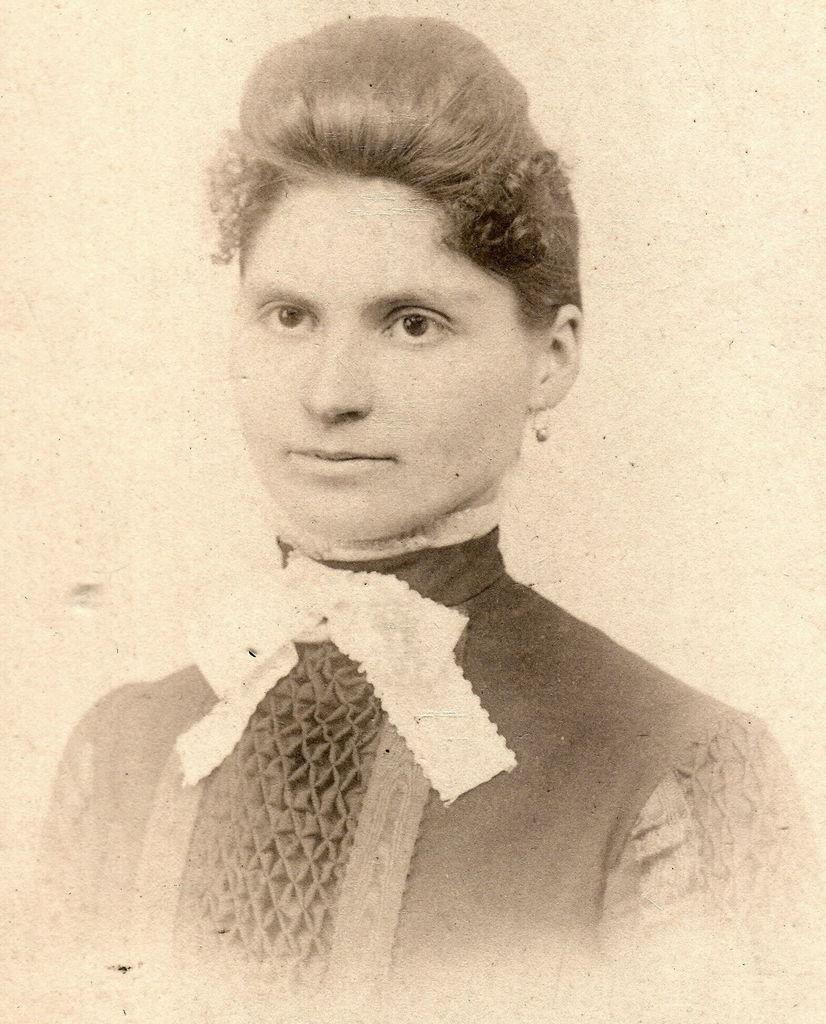What type of visual is depicted in the image? The image is a poster. Who or what is featured on the poster? There is a woman in the image. What type of food is the woman eating in the image? There is no food present in the image, as it only features a woman on a poster. What is the woman's role as a manager in the image? There is no indication of the woman's role as a manager in the image, as it only features her on a poster. 